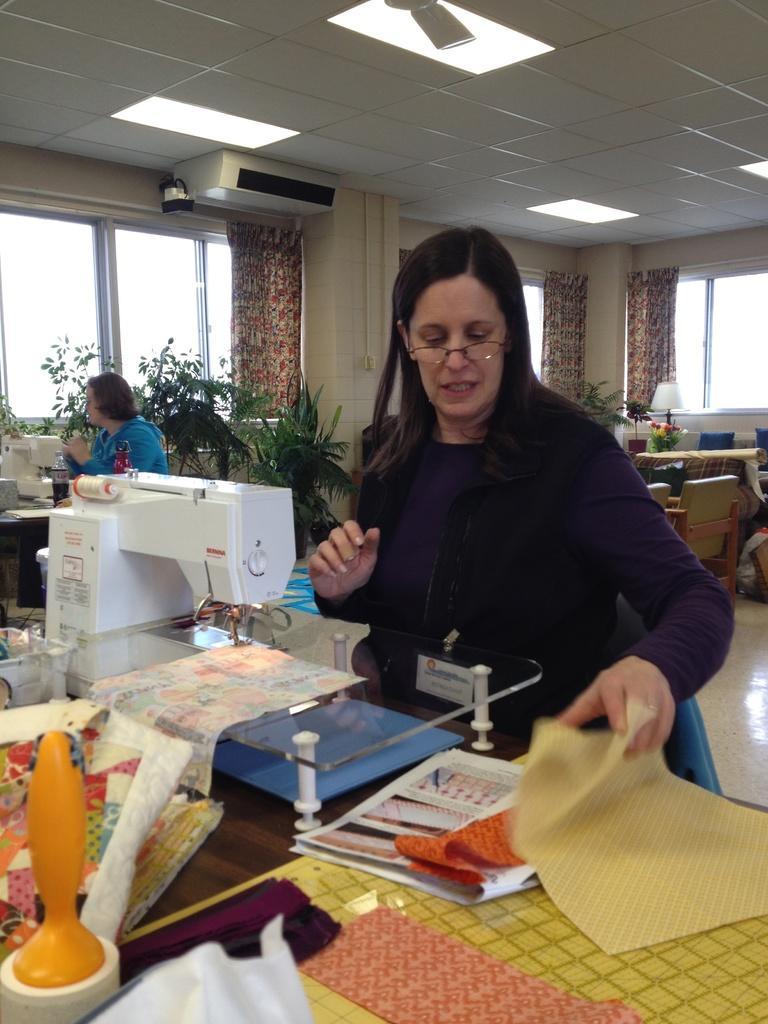How would you summarize this image in a sentence or two? There are 2 women in this room besides stitching machine. Behind them there are water plants,window,curtain,lamp,table and chairs. On the roof top there is an AC and lights. 